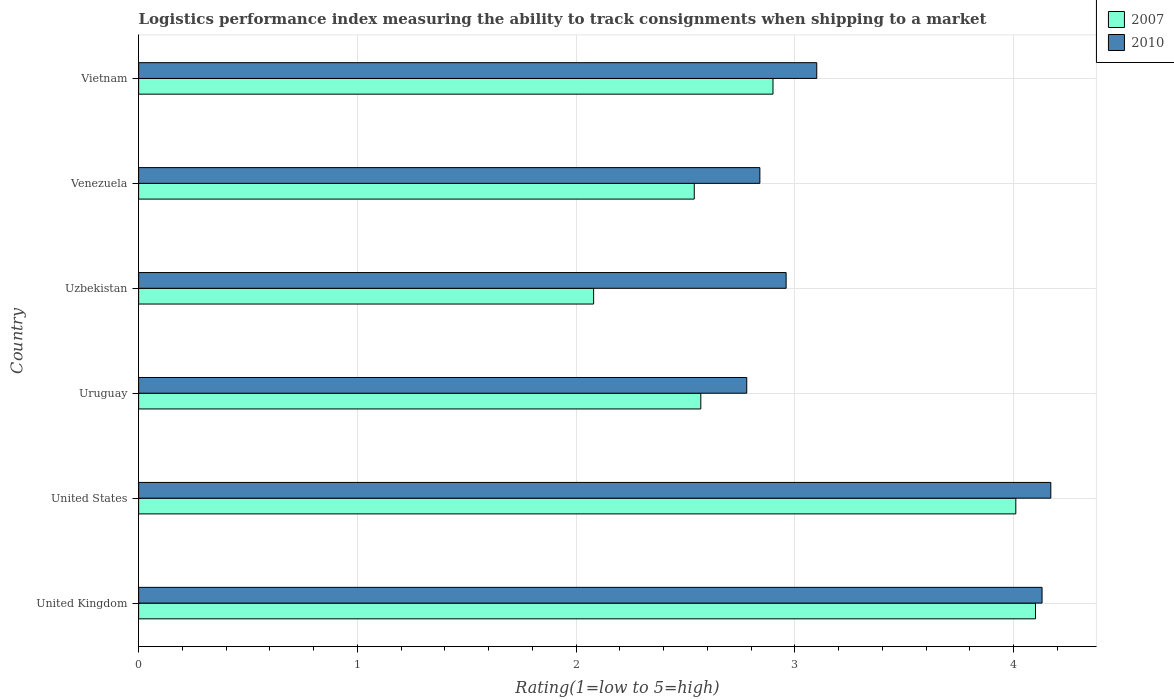How many different coloured bars are there?
Offer a terse response. 2. How many groups of bars are there?
Your answer should be very brief. 6. How many bars are there on the 5th tick from the top?
Ensure brevity in your answer.  2. What is the label of the 2nd group of bars from the top?
Give a very brief answer. Venezuela. In how many cases, is the number of bars for a given country not equal to the number of legend labels?
Offer a terse response. 0. What is the Logistic performance index in 2010 in United States?
Offer a very short reply. 4.17. Across all countries, what is the maximum Logistic performance index in 2010?
Offer a terse response. 4.17. Across all countries, what is the minimum Logistic performance index in 2010?
Keep it short and to the point. 2.78. In which country was the Logistic performance index in 2010 minimum?
Give a very brief answer. Uruguay. What is the difference between the Logistic performance index in 2010 in Uruguay and that in Venezuela?
Provide a succinct answer. -0.06. What is the difference between the Logistic performance index in 2010 in Venezuela and the Logistic performance index in 2007 in United States?
Give a very brief answer. -1.17. What is the average Logistic performance index in 2010 per country?
Your answer should be compact. 3.33. What is the difference between the Logistic performance index in 2007 and Logistic performance index in 2010 in Venezuela?
Make the answer very short. -0.3. In how many countries, is the Logistic performance index in 2010 greater than 4 ?
Your answer should be compact. 2. What is the ratio of the Logistic performance index in 2010 in United States to that in Uruguay?
Provide a short and direct response. 1.5. Is the difference between the Logistic performance index in 2007 in United States and Uruguay greater than the difference between the Logistic performance index in 2010 in United States and Uruguay?
Offer a terse response. Yes. What is the difference between the highest and the second highest Logistic performance index in 2007?
Ensure brevity in your answer.  0.09. What is the difference between the highest and the lowest Logistic performance index in 2007?
Give a very brief answer. 2.02. How many countries are there in the graph?
Your response must be concise. 6. What is the difference between two consecutive major ticks on the X-axis?
Provide a short and direct response. 1. Are the values on the major ticks of X-axis written in scientific E-notation?
Ensure brevity in your answer.  No. Where does the legend appear in the graph?
Ensure brevity in your answer.  Top right. How many legend labels are there?
Offer a very short reply. 2. How are the legend labels stacked?
Offer a terse response. Vertical. What is the title of the graph?
Provide a short and direct response. Logistics performance index measuring the ability to track consignments when shipping to a market. What is the label or title of the X-axis?
Offer a very short reply. Rating(1=low to 5=high). What is the label or title of the Y-axis?
Your answer should be very brief. Country. What is the Rating(1=low to 5=high) in 2007 in United Kingdom?
Give a very brief answer. 4.1. What is the Rating(1=low to 5=high) of 2010 in United Kingdom?
Ensure brevity in your answer.  4.13. What is the Rating(1=low to 5=high) of 2007 in United States?
Keep it short and to the point. 4.01. What is the Rating(1=low to 5=high) in 2010 in United States?
Provide a short and direct response. 4.17. What is the Rating(1=low to 5=high) of 2007 in Uruguay?
Provide a succinct answer. 2.57. What is the Rating(1=low to 5=high) of 2010 in Uruguay?
Provide a succinct answer. 2.78. What is the Rating(1=low to 5=high) in 2007 in Uzbekistan?
Give a very brief answer. 2.08. What is the Rating(1=low to 5=high) in 2010 in Uzbekistan?
Provide a succinct answer. 2.96. What is the Rating(1=low to 5=high) in 2007 in Venezuela?
Provide a short and direct response. 2.54. What is the Rating(1=low to 5=high) in 2010 in Venezuela?
Ensure brevity in your answer.  2.84. What is the Rating(1=low to 5=high) in 2007 in Vietnam?
Your answer should be compact. 2.9. What is the Rating(1=low to 5=high) of 2010 in Vietnam?
Your answer should be compact. 3.1. Across all countries, what is the maximum Rating(1=low to 5=high) of 2007?
Provide a succinct answer. 4.1. Across all countries, what is the maximum Rating(1=low to 5=high) in 2010?
Provide a succinct answer. 4.17. Across all countries, what is the minimum Rating(1=low to 5=high) in 2007?
Provide a short and direct response. 2.08. Across all countries, what is the minimum Rating(1=low to 5=high) of 2010?
Provide a succinct answer. 2.78. What is the total Rating(1=low to 5=high) of 2007 in the graph?
Your response must be concise. 18.2. What is the total Rating(1=low to 5=high) of 2010 in the graph?
Provide a succinct answer. 19.98. What is the difference between the Rating(1=low to 5=high) in 2007 in United Kingdom and that in United States?
Provide a short and direct response. 0.09. What is the difference between the Rating(1=low to 5=high) in 2010 in United Kingdom and that in United States?
Ensure brevity in your answer.  -0.04. What is the difference between the Rating(1=low to 5=high) in 2007 in United Kingdom and that in Uruguay?
Offer a very short reply. 1.53. What is the difference between the Rating(1=low to 5=high) of 2010 in United Kingdom and that in Uruguay?
Ensure brevity in your answer.  1.35. What is the difference between the Rating(1=low to 5=high) in 2007 in United Kingdom and that in Uzbekistan?
Give a very brief answer. 2.02. What is the difference between the Rating(1=low to 5=high) in 2010 in United Kingdom and that in Uzbekistan?
Provide a short and direct response. 1.17. What is the difference between the Rating(1=low to 5=high) of 2007 in United Kingdom and that in Venezuela?
Make the answer very short. 1.56. What is the difference between the Rating(1=low to 5=high) of 2010 in United Kingdom and that in Venezuela?
Provide a succinct answer. 1.29. What is the difference between the Rating(1=low to 5=high) of 2007 in United Kingdom and that in Vietnam?
Your answer should be very brief. 1.2. What is the difference between the Rating(1=low to 5=high) of 2010 in United Kingdom and that in Vietnam?
Your answer should be very brief. 1.03. What is the difference between the Rating(1=low to 5=high) in 2007 in United States and that in Uruguay?
Offer a terse response. 1.44. What is the difference between the Rating(1=low to 5=high) in 2010 in United States and that in Uruguay?
Your answer should be very brief. 1.39. What is the difference between the Rating(1=low to 5=high) of 2007 in United States and that in Uzbekistan?
Ensure brevity in your answer.  1.93. What is the difference between the Rating(1=low to 5=high) in 2010 in United States and that in Uzbekistan?
Your answer should be very brief. 1.21. What is the difference between the Rating(1=low to 5=high) of 2007 in United States and that in Venezuela?
Make the answer very short. 1.47. What is the difference between the Rating(1=low to 5=high) in 2010 in United States and that in Venezuela?
Provide a succinct answer. 1.33. What is the difference between the Rating(1=low to 5=high) in 2007 in United States and that in Vietnam?
Offer a very short reply. 1.11. What is the difference between the Rating(1=low to 5=high) of 2010 in United States and that in Vietnam?
Make the answer very short. 1.07. What is the difference between the Rating(1=low to 5=high) in 2007 in Uruguay and that in Uzbekistan?
Provide a succinct answer. 0.49. What is the difference between the Rating(1=low to 5=high) in 2010 in Uruguay and that in Uzbekistan?
Your response must be concise. -0.18. What is the difference between the Rating(1=low to 5=high) of 2007 in Uruguay and that in Venezuela?
Give a very brief answer. 0.03. What is the difference between the Rating(1=low to 5=high) in 2010 in Uruguay and that in Venezuela?
Offer a very short reply. -0.06. What is the difference between the Rating(1=low to 5=high) of 2007 in Uruguay and that in Vietnam?
Your answer should be compact. -0.33. What is the difference between the Rating(1=low to 5=high) in 2010 in Uruguay and that in Vietnam?
Keep it short and to the point. -0.32. What is the difference between the Rating(1=low to 5=high) of 2007 in Uzbekistan and that in Venezuela?
Give a very brief answer. -0.46. What is the difference between the Rating(1=low to 5=high) of 2010 in Uzbekistan and that in Venezuela?
Make the answer very short. 0.12. What is the difference between the Rating(1=low to 5=high) of 2007 in Uzbekistan and that in Vietnam?
Make the answer very short. -0.82. What is the difference between the Rating(1=low to 5=high) of 2010 in Uzbekistan and that in Vietnam?
Provide a succinct answer. -0.14. What is the difference between the Rating(1=low to 5=high) in 2007 in Venezuela and that in Vietnam?
Your response must be concise. -0.36. What is the difference between the Rating(1=low to 5=high) of 2010 in Venezuela and that in Vietnam?
Keep it short and to the point. -0.26. What is the difference between the Rating(1=low to 5=high) of 2007 in United Kingdom and the Rating(1=low to 5=high) of 2010 in United States?
Your answer should be compact. -0.07. What is the difference between the Rating(1=low to 5=high) in 2007 in United Kingdom and the Rating(1=low to 5=high) in 2010 in Uruguay?
Provide a succinct answer. 1.32. What is the difference between the Rating(1=low to 5=high) of 2007 in United Kingdom and the Rating(1=low to 5=high) of 2010 in Uzbekistan?
Your response must be concise. 1.14. What is the difference between the Rating(1=low to 5=high) of 2007 in United Kingdom and the Rating(1=low to 5=high) of 2010 in Venezuela?
Keep it short and to the point. 1.26. What is the difference between the Rating(1=low to 5=high) in 2007 in United Kingdom and the Rating(1=low to 5=high) in 2010 in Vietnam?
Make the answer very short. 1. What is the difference between the Rating(1=low to 5=high) of 2007 in United States and the Rating(1=low to 5=high) of 2010 in Uruguay?
Keep it short and to the point. 1.23. What is the difference between the Rating(1=low to 5=high) in 2007 in United States and the Rating(1=low to 5=high) in 2010 in Venezuela?
Offer a very short reply. 1.17. What is the difference between the Rating(1=low to 5=high) in 2007 in United States and the Rating(1=low to 5=high) in 2010 in Vietnam?
Your answer should be compact. 0.91. What is the difference between the Rating(1=low to 5=high) of 2007 in Uruguay and the Rating(1=low to 5=high) of 2010 in Uzbekistan?
Keep it short and to the point. -0.39. What is the difference between the Rating(1=low to 5=high) in 2007 in Uruguay and the Rating(1=low to 5=high) in 2010 in Venezuela?
Provide a short and direct response. -0.27. What is the difference between the Rating(1=low to 5=high) in 2007 in Uruguay and the Rating(1=low to 5=high) in 2010 in Vietnam?
Offer a very short reply. -0.53. What is the difference between the Rating(1=low to 5=high) of 2007 in Uzbekistan and the Rating(1=low to 5=high) of 2010 in Venezuela?
Offer a terse response. -0.76. What is the difference between the Rating(1=low to 5=high) of 2007 in Uzbekistan and the Rating(1=low to 5=high) of 2010 in Vietnam?
Offer a very short reply. -1.02. What is the difference between the Rating(1=low to 5=high) in 2007 in Venezuela and the Rating(1=low to 5=high) in 2010 in Vietnam?
Make the answer very short. -0.56. What is the average Rating(1=low to 5=high) in 2007 per country?
Make the answer very short. 3.03. What is the average Rating(1=low to 5=high) of 2010 per country?
Make the answer very short. 3.33. What is the difference between the Rating(1=low to 5=high) in 2007 and Rating(1=low to 5=high) in 2010 in United Kingdom?
Your answer should be very brief. -0.03. What is the difference between the Rating(1=low to 5=high) of 2007 and Rating(1=low to 5=high) of 2010 in United States?
Make the answer very short. -0.16. What is the difference between the Rating(1=low to 5=high) of 2007 and Rating(1=low to 5=high) of 2010 in Uruguay?
Your answer should be compact. -0.21. What is the difference between the Rating(1=low to 5=high) in 2007 and Rating(1=low to 5=high) in 2010 in Uzbekistan?
Ensure brevity in your answer.  -0.88. What is the ratio of the Rating(1=low to 5=high) in 2007 in United Kingdom to that in United States?
Your answer should be very brief. 1.02. What is the ratio of the Rating(1=low to 5=high) of 2010 in United Kingdom to that in United States?
Give a very brief answer. 0.99. What is the ratio of the Rating(1=low to 5=high) in 2007 in United Kingdom to that in Uruguay?
Ensure brevity in your answer.  1.6. What is the ratio of the Rating(1=low to 5=high) of 2010 in United Kingdom to that in Uruguay?
Offer a terse response. 1.49. What is the ratio of the Rating(1=low to 5=high) of 2007 in United Kingdom to that in Uzbekistan?
Your response must be concise. 1.97. What is the ratio of the Rating(1=low to 5=high) of 2010 in United Kingdom to that in Uzbekistan?
Provide a succinct answer. 1.4. What is the ratio of the Rating(1=low to 5=high) in 2007 in United Kingdom to that in Venezuela?
Offer a terse response. 1.61. What is the ratio of the Rating(1=low to 5=high) of 2010 in United Kingdom to that in Venezuela?
Your answer should be very brief. 1.45. What is the ratio of the Rating(1=low to 5=high) in 2007 in United Kingdom to that in Vietnam?
Your response must be concise. 1.41. What is the ratio of the Rating(1=low to 5=high) of 2010 in United Kingdom to that in Vietnam?
Make the answer very short. 1.33. What is the ratio of the Rating(1=low to 5=high) of 2007 in United States to that in Uruguay?
Offer a terse response. 1.56. What is the ratio of the Rating(1=low to 5=high) of 2007 in United States to that in Uzbekistan?
Give a very brief answer. 1.93. What is the ratio of the Rating(1=low to 5=high) of 2010 in United States to that in Uzbekistan?
Provide a short and direct response. 1.41. What is the ratio of the Rating(1=low to 5=high) in 2007 in United States to that in Venezuela?
Provide a short and direct response. 1.58. What is the ratio of the Rating(1=low to 5=high) in 2010 in United States to that in Venezuela?
Provide a short and direct response. 1.47. What is the ratio of the Rating(1=low to 5=high) of 2007 in United States to that in Vietnam?
Offer a very short reply. 1.38. What is the ratio of the Rating(1=low to 5=high) of 2010 in United States to that in Vietnam?
Ensure brevity in your answer.  1.35. What is the ratio of the Rating(1=low to 5=high) in 2007 in Uruguay to that in Uzbekistan?
Your response must be concise. 1.24. What is the ratio of the Rating(1=low to 5=high) in 2010 in Uruguay to that in Uzbekistan?
Offer a very short reply. 0.94. What is the ratio of the Rating(1=low to 5=high) in 2007 in Uruguay to that in Venezuela?
Offer a terse response. 1.01. What is the ratio of the Rating(1=low to 5=high) in 2010 in Uruguay to that in Venezuela?
Give a very brief answer. 0.98. What is the ratio of the Rating(1=low to 5=high) in 2007 in Uruguay to that in Vietnam?
Offer a terse response. 0.89. What is the ratio of the Rating(1=low to 5=high) in 2010 in Uruguay to that in Vietnam?
Your answer should be very brief. 0.9. What is the ratio of the Rating(1=low to 5=high) of 2007 in Uzbekistan to that in Venezuela?
Ensure brevity in your answer.  0.82. What is the ratio of the Rating(1=low to 5=high) of 2010 in Uzbekistan to that in Venezuela?
Your response must be concise. 1.04. What is the ratio of the Rating(1=low to 5=high) of 2007 in Uzbekistan to that in Vietnam?
Provide a short and direct response. 0.72. What is the ratio of the Rating(1=low to 5=high) of 2010 in Uzbekistan to that in Vietnam?
Offer a very short reply. 0.95. What is the ratio of the Rating(1=low to 5=high) of 2007 in Venezuela to that in Vietnam?
Provide a short and direct response. 0.88. What is the ratio of the Rating(1=low to 5=high) of 2010 in Venezuela to that in Vietnam?
Your answer should be very brief. 0.92. What is the difference between the highest and the second highest Rating(1=low to 5=high) of 2007?
Make the answer very short. 0.09. What is the difference between the highest and the lowest Rating(1=low to 5=high) in 2007?
Your answer should be very brief. 2.02. What is the difference between the highest and the lowest Rating(1=low to 5=high) of 2010?
Give a very brief answer. 1.39. 